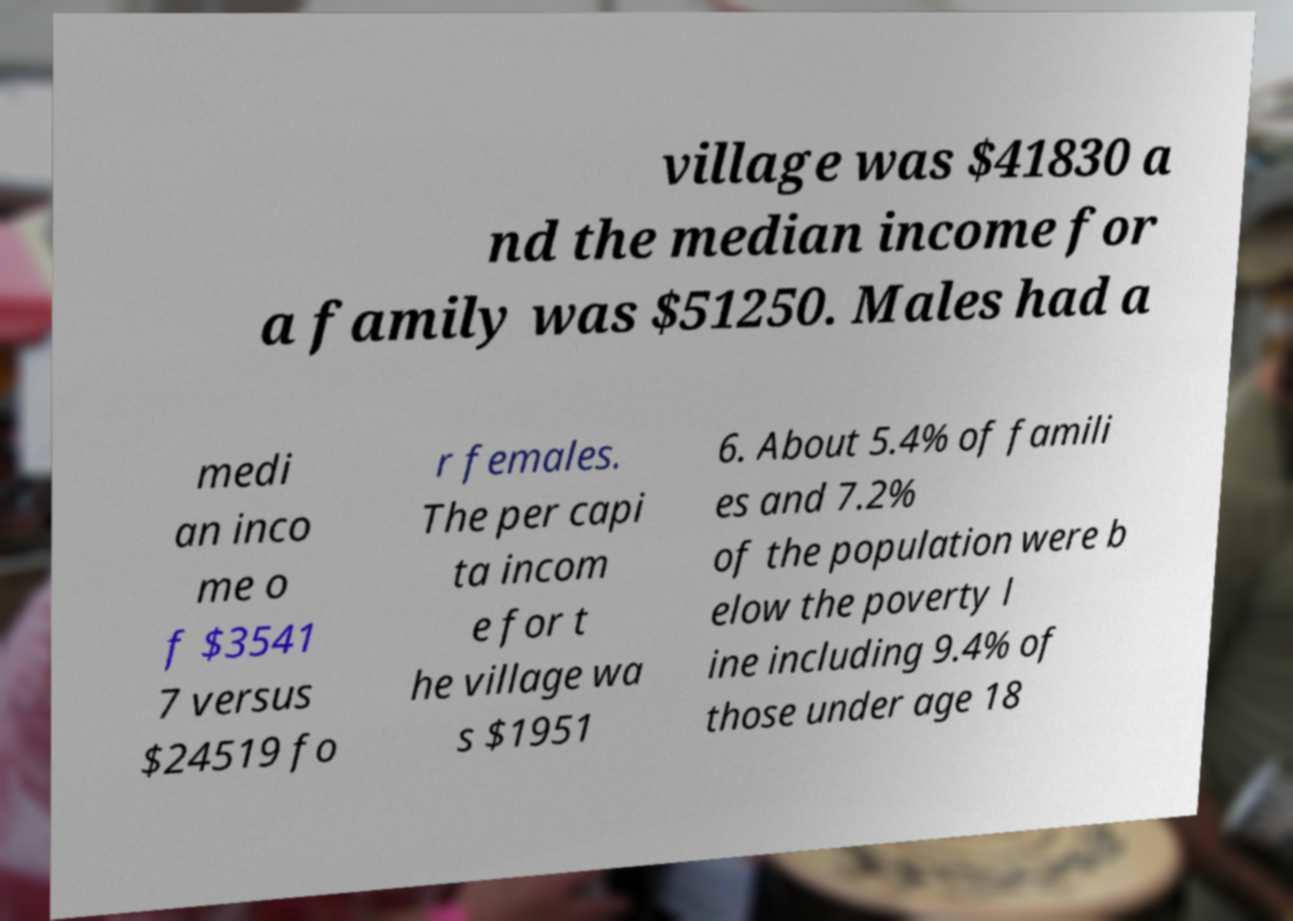There's text embedded in this image that I need extracted. Can you transcribe it verbatim? village was $41830 a nd the median income for a family was $51250. Males had a medi an inco me o f $3541 7 versus $24519 fo r females. The per capi ta incom e for t he village wa s $1951 6. About 5.4% of famili es and 7.2% of the population were b elow the poverty l ine including 9.4% of those under age 18 